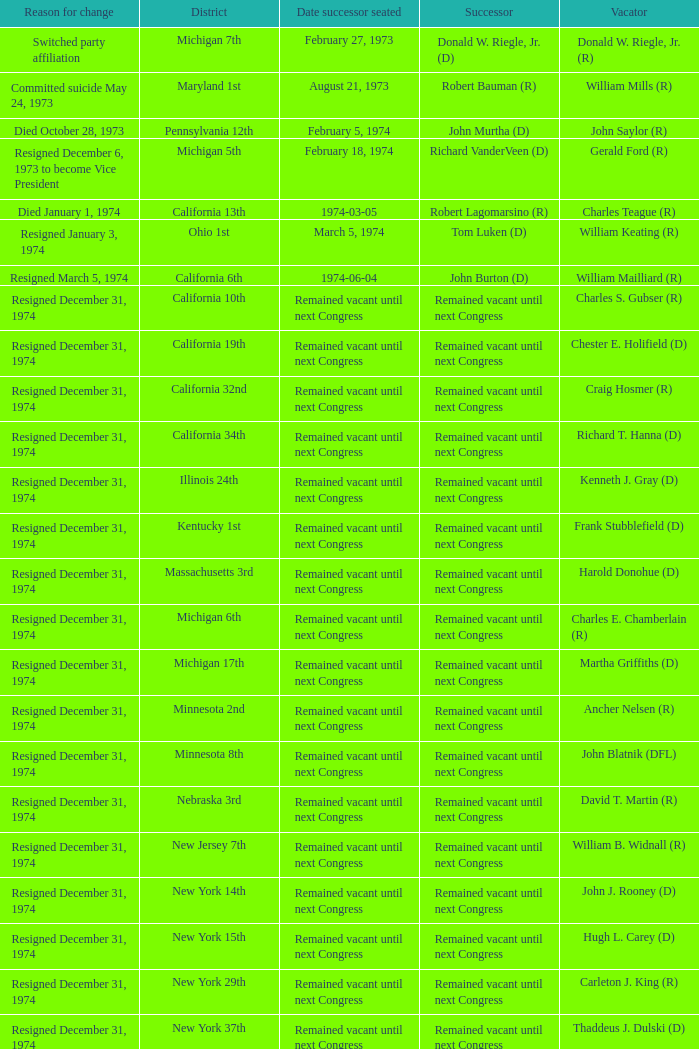Who was the vacator when the date successor seated was august 21, 1973? William Mills (R). Could you help me parse every detail presented in this table? {'header': ['Reason for change', 'District', 'Date successor seated', 'Successor', 'Vacator'], 'rows': [['Switched party affiliation', 'Michigan 7th', 'February 27, 1973', 'Donald W. Riegle, Jr. (D)', 'Donald W. Riegle, Jr. (R)'], ['Committed suicide May 24, 1973', 'Maryland 1st', 'August 21, 1973', 'Robert Bauman (R)', 'William Mills (R)'], ['Died October 28, 1973', 'Pennsylvania 12th', 'February 5, 1974', 'John Murtha (D)', 'John Saylor (R)'], ['Resigned December 6, 1973 to become Vice President', 'Michigan 5th', 'February 18, 1974', 'Richard VanderVeen (D)', 'Gerald Ford (R)'], ['Died January 1, 1974', 'California 13th', '1974-03-05', 'Robert Lagomarsino (R)', 'Charles Teague (R)'], ['Resigned January 3, 1974', 'Ohio 1st', 'March 5, 1974', 'Tom Luken (D)', 'William Keating (R)'], ['Resigned March 5, 1974', 'California 6th', '1974-06-04', 'John Burton (D)', 'William Mailliard (R)'], ['Resigned December 31, 1974', 'California 10th', 'Remained vacant until next Congress', 'Remained vacant until next Congress', 'Charles S. Gubser (R)'], ['Resigned December 31, 1974', 'California 19th', 'Remained vacant until next Congress', 'Remained vacant until next Congress', 'Chester E. Holifield (D)'], ['Resigned December 31, 1974', 'California 32nd', 'Remained vacant until next Congress', 'Remained vacant until next Congress', 'Craig Hosmer (R)'], ['Resigned December 31, 1974', 'California 34th', 'Remained vacant until next Congress', 'Remained vacant until next Congress', 'Richard T. Hanna (D)'], ['Resigned December 31, 1974', 'Illinois 24th', 'Remained vacant until next Congress', 'Remained vacant until next Congress', 'Kenneth J. Gray (D)'], ['Resigned December 31, 1974', 'Kentucky 1st', 'Remained vacant until next Congress', 'Remained vacant until next Congress', 'Frank Stubblefield (D)'], ['Resigned December 31, 1974', 'Massachusetts 3rd', 'Remained vacant until next Congress', 'Remained vacant until next Congress', 'Harold Donohue (D)'], ['Resigned December 31, 1974', 'Michigan 6th', 'Remained vacant until next Congress', 'Remained vacant until next Congress', 'Charles E. Chamberlain (R)'], ['Resigned December 31, 1974', 'Michigan 17th', 'Remained vacant until next Congress', 'Remained vacant until next Congress', 'Martha Griffiths (D)'], ['Resigned December 31, 1974', 'Minnesota 2nd', 'Remained vacant until next Congress', 'Remained vacant until next Congress', 'Ancher Nelsen (R)'], ['Resigned December 31, 1974', 'Minnesota 8th', 'Remained vacant until next Congress', 'Remained vacant until next Congress', 'John Blatnik (DFL)'], ['Resigned December 31, 1974', 'Nebraska 3rd', 'Remained vacant until next Congress', 'Remained vacant until next Congress', 'David T. Martin (R)'], ['Resigned December 31, 1974', 'New Jersey 7th', 'Remained vacant until next Congress', 'Remained vacant until next Congress', 'William B. Widnall (R)'], ['Resigned December 31, 1974', 'New York 14th', 'Remained vacant until next Congress', 'Remained vacant until next Congress', 'John J. Rooney (D)'], ['Resigned December 31, 1974', 'New York 15th', 'Remained vacant until next Congress', 'Remained vacant until next Congress', 'Hugh L. Carey (D)'], ['Resigned December 31, 1974', 'New York 29th', 'Remained vacant until next Congress', 'Remained vacant until next Congress', 'Carleton J. King (R)'], ['Resigned December 31, 1974', 'New York 37th', 'Remained vacant until next Congress', 'Remained vacant until next Congress', 'Thaddeus J. Dulski (D)'], ['Resigned December 31, 1974', 'Ohio 23rd', 'Remained vacant until next Congress', 'Remained vacant until next Congress', 'William Minshall (R)'], ['Resigned December 31, 1974', 'Oregon 3rd', 'Remained vacant until next Congress', 'Remained vacant until next Congress', 'Edith S. Green (D)'], ['Resigned December 31, 1974', 'Pennsylvania 25th', 'Remained vacant until next Congress', 'Remained vacant until next Congress', 'Frank M. Clark (D)'], ['Resigned December 31, 1974', 'South Carolina 3rd', 'Remained vacant until next Congress', 'Remained vacant until next Congress', 'W.J. Bryan Dorn (D)'], ['Resigned December 31, 1974', 'South Carolina 5th', 'Remained vacant until next Congress', 'Remained vacant until next Congress', 'Thomas S. Gettys (D)'], ['Resigned December 31, 1974', 'Texas 21st', 'Remained vacant until next Congress', 'Remained vacant until next Congress', 'O. C. Fisher (D)'], ['Resigned December 31, 1974', 'Washington 3rd', 'Remained vacant until next Congress', 'Remained vacant until next Congress', 'Julia B. Hansen (D)'], ['Resigned December 31, 1974', 'Wisconsin 3rd', 'Remained vacant until next Congress', 'Remained vacant until next Congress', 'Vernon W. Thomson (R)']]} 